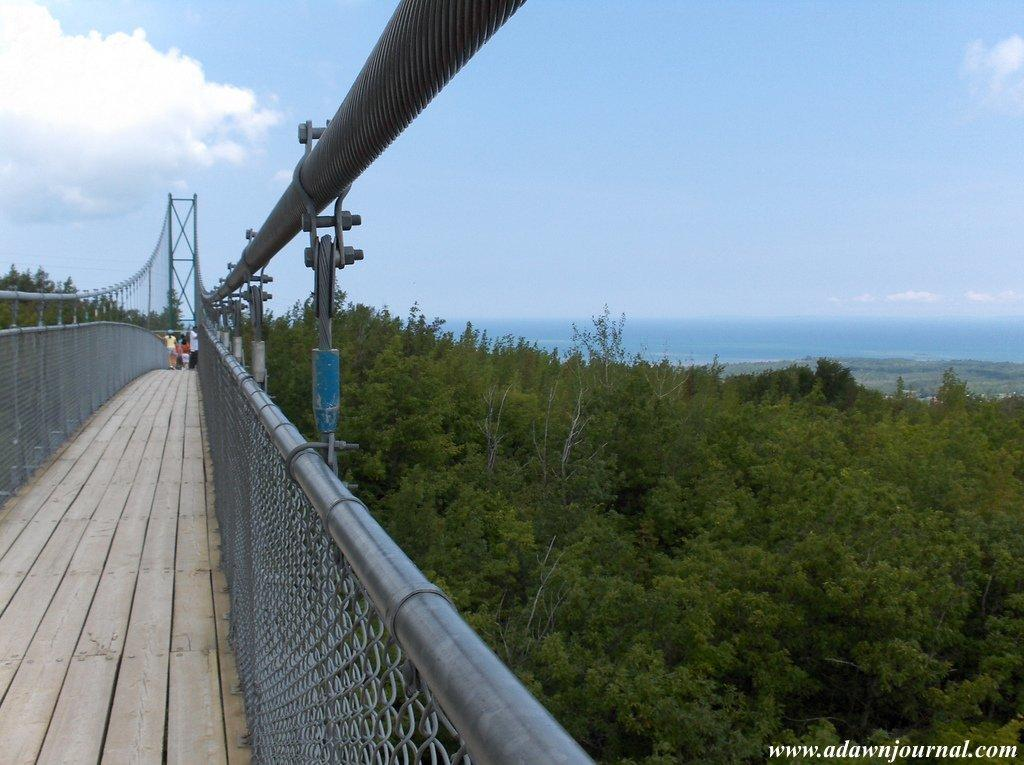What type of structure is present in the image? There is a foot over bridge in the image. What other elements can be seen in the image besides the foot over bridge? There are trees in the image. How would you describe the sky in the image? The sky is blue and cloudy in the image. Is there any text present in the image? Yes, there is text at the bottom right corner of the image. How many chickens are visible on the foot over bridge in the image? There are no chickens present in the image; it features a foot over bridge, trees, and a blue and cloudy sky. Is anyone wearing a mask in the image? There is no indication of anyone wearing a mask in the image. 